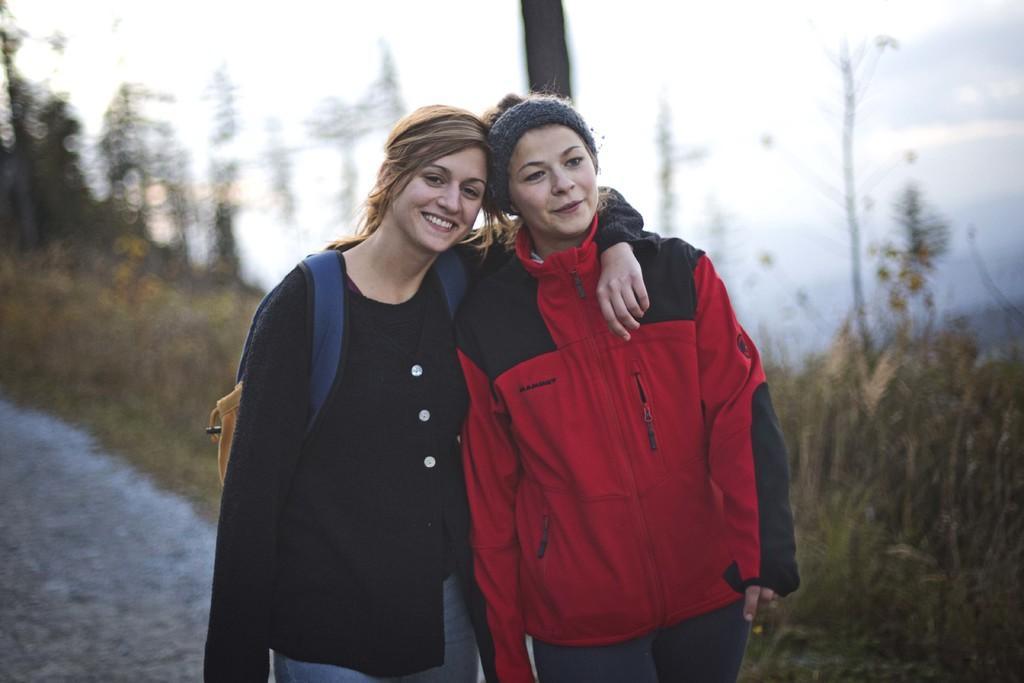Can you describe this image briefly? In this image I can see a beautiful woman is holding another woman and smiling she wore black color top and jeans trouser. This woman wore red color coat, behind them there are trees in this image. 